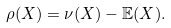Convert formula to latex. <formula><loc_0><loc_0><loc_500><loc_500>\rho ( X ) = \nu ( X ) - \mathbb { E } ( X ) .</formula> 